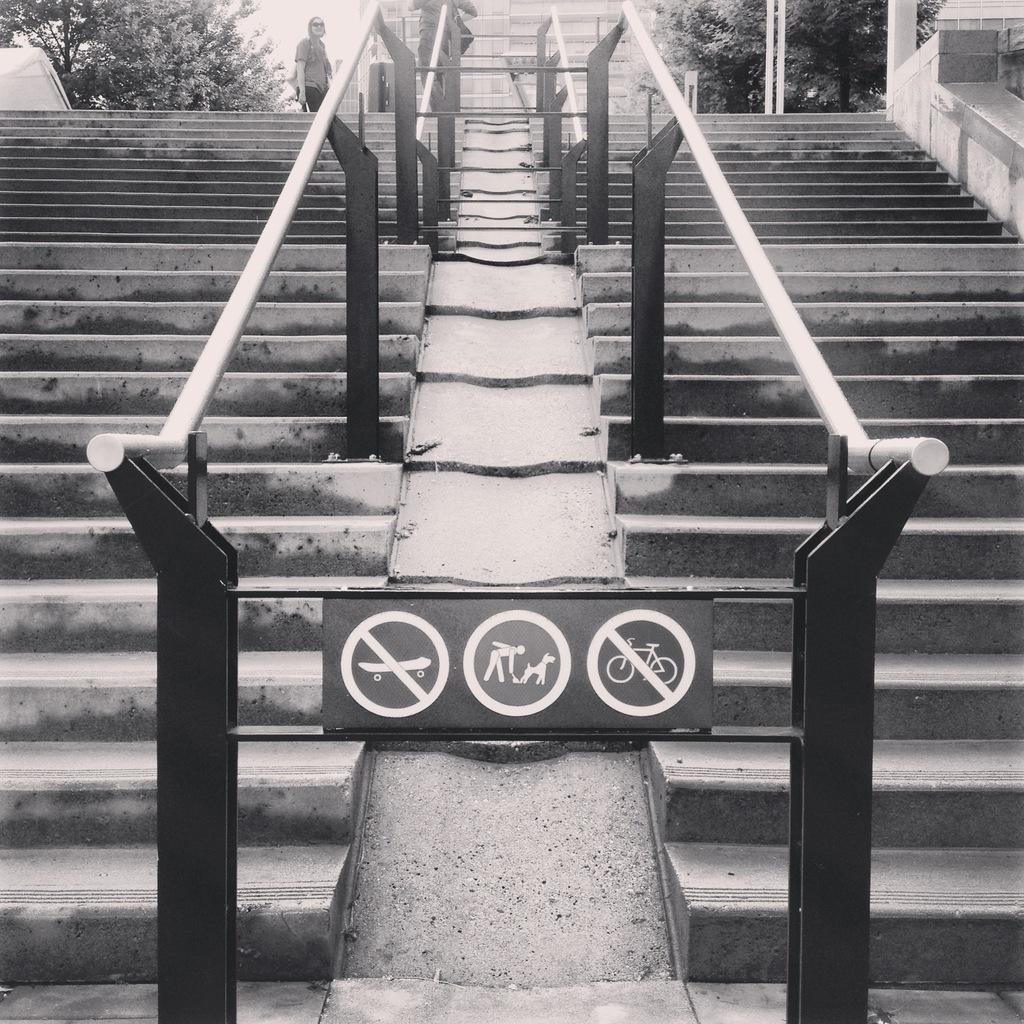Could you give a brief overview of what you see in this image? In the center of the image there is a board. There are stairs. There is a metal fence. In the background of the image there is a person. There are trees. There are buildings. 